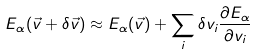Convert formula to latex. <formula><loc_0><loc_0><loc_500><loc_500>E _ { \alpha } ( \vec { v } + \delta \vec { v } ) \approx E _ { \alpha } ( \vec { v } ) + \sum _ { i } \delta v _ { i } \frac { \partial E _ { \alpha } } { \partial v _ { i } }</formula> 